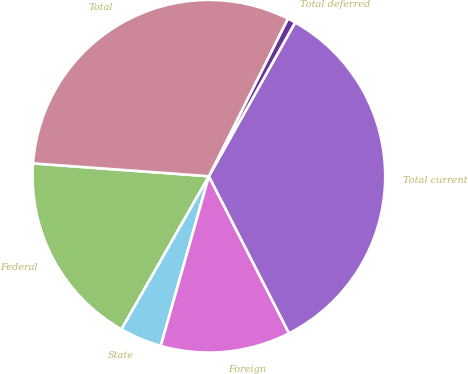<chart> <loc_0><loc_0><loc_500><loc_500><pie_chart><fcel>Federal<fcel>State<fcel>Foreign<fcel>Total current<fcel>Total deferred<fcel>Total<nl><fcel>17.9%<fcel>3.86%<fcel>11.91%<fcel>34.35%<fcel>0.74%<fcel>31.23%<nl></chart> 